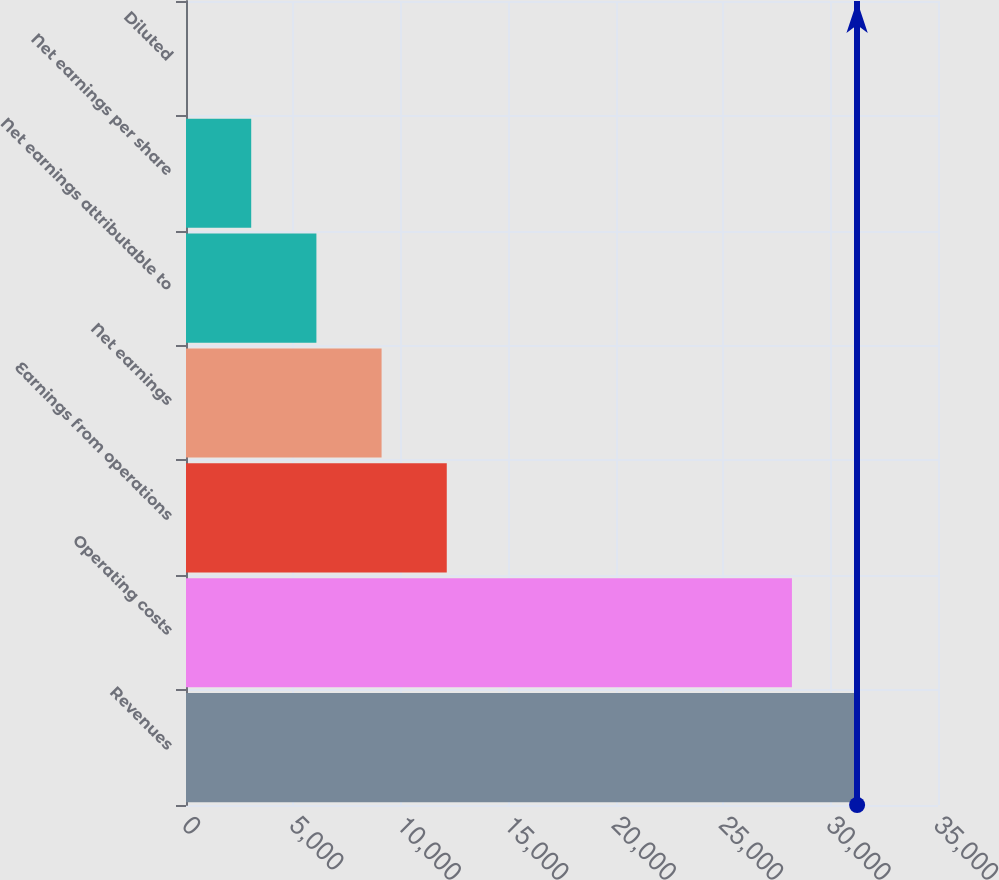Convert chart. <chart><loc_0><loc_0><loc_500><loc_500><bar_chart><fcel>Revenues<fcel>Operating costs<fcel>Earnings from operations<fcel>Net earnings<fcel>Net earnings attributable to<fcel>Net earnings per share<fcel>Diluted<nl><fcel>31234.9<fcel>28201<fcel>12136.7<fcel>9102.8<fcel>6068.92<fcel>3035.04<fcel>1.16<nl></chart> 